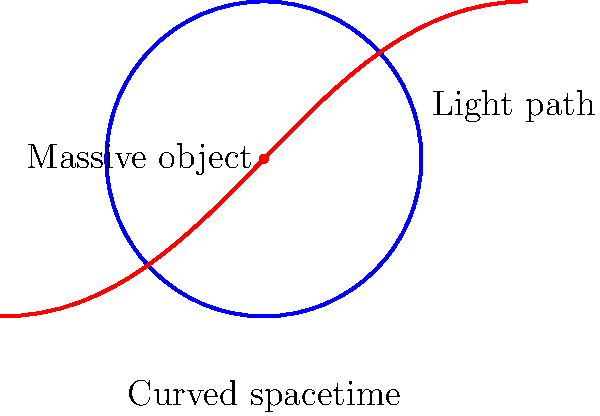In the diagram above, we see a representation of curved spacetime and a light path. This illustrates a fundamental concept in non-Euclidean geometry and general relativity. What is the primary reason for the bending of light in this scenario, and how does it relate to the curvature of spacetime? To understand this concept, let's break it down step-by-step:

1. In Euclidean geometry, light would travel in straight lines. However, the diagram shows a curved path for light.

2. The blue curve represents curved spacetime, which is a result of the presence of a massive object (shown as a red dot).

3. According to Einstein's theory of general relativity, massive objects cause spacetime to curve around them.

4. Light always follows the shortest path between two points. In curved spacetime, this shortest path is not a straight line but a curved one.

5. The red curve shows the path of light as it travels through this curved spacetime.

6. This bending of light is not due to any force acting on the light itself, but rather due to the geometry of space being altered by the massive object.

7. This phenomenon is an example of geodesic motion in non-Euclidean geometry, where the "straight lines" of the geometry are curves in the embedding space.

8. The amount of bending depends on the mass of the object and how close the light passes to it.

This concept is crucial in understanding gravitational lensing, where distant galaxies can act as "cosmic magnifying glasses," bending and magnifying light from even more distant objects behind them.
Answer: Spacetime curvature caused by massive objects 